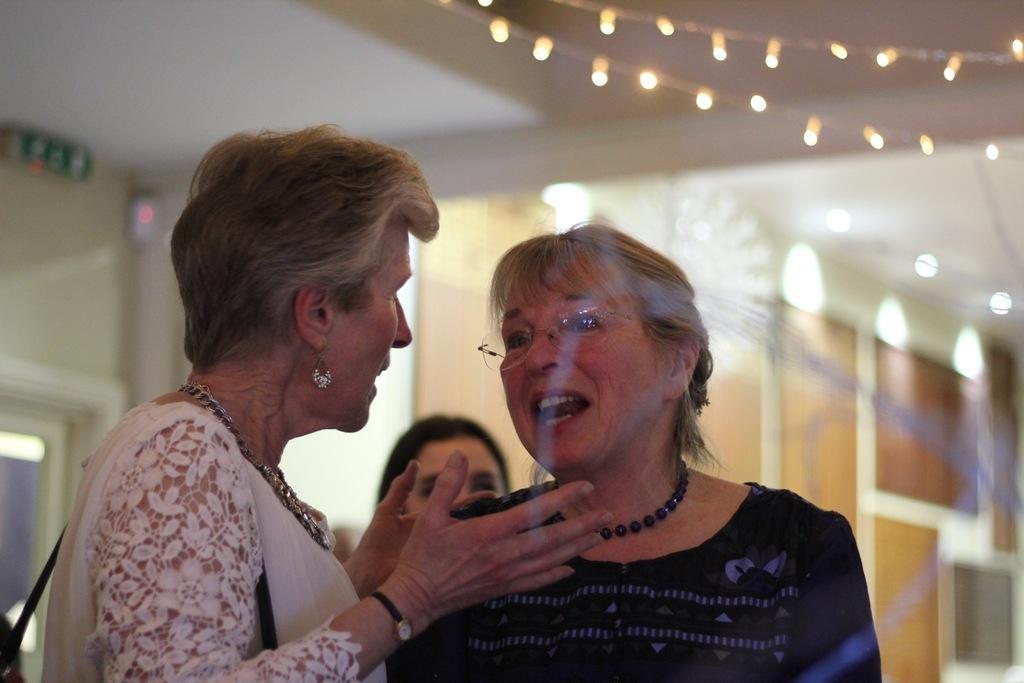Can you describe this image briefly? In this image in the foreground I can see two women standing and talking to each other. I can see another woman behind them and the background is blurred with some lights.  